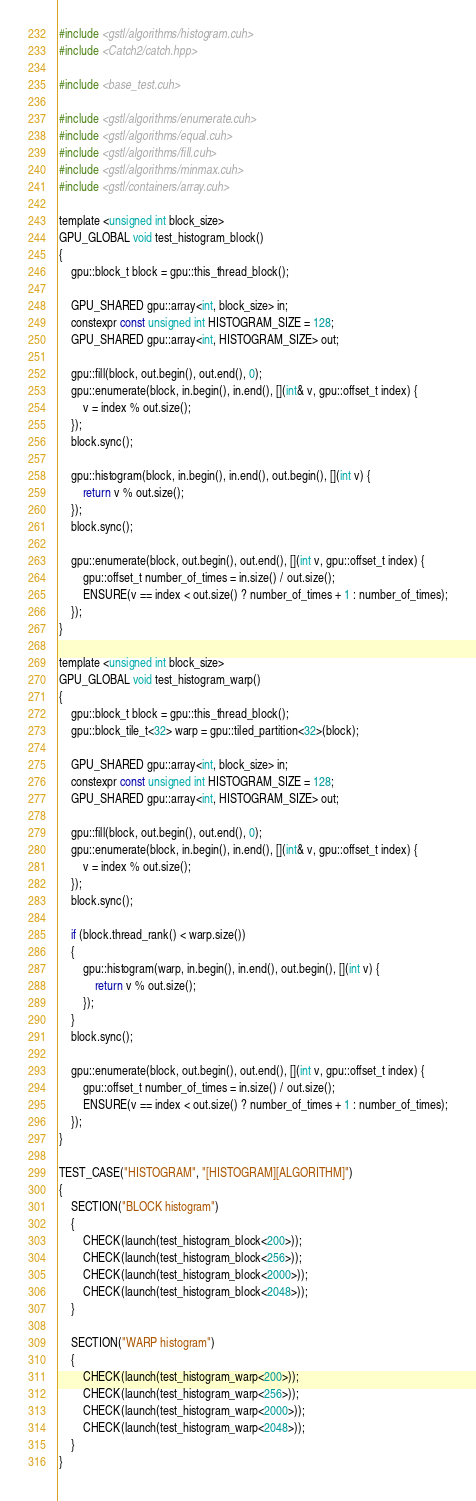Convert code to text. <code><loc_0><loc_0><loc_500><loc_500><_Cuda_>#include <gstl/algorithms/histogram.cuh>
#include <Catch2/catch.hpp>

#include <base_test.cuh>

#include <gstl/algorithms/enumerate.cuh>
#include <gstl/algorithms/equal.cuh>
#include <gstl/algorithms/fill.cuh>
#include <gstl/algorithms/minmax.cuh>
#include <gstl/containers/array.cuh>

template <unsigned int block_size>
GPU_GLOBAL void test_histogram_block()
{
	gpu::block_t block = gpu::this_thread_block();

	GPU_SHARED gpu::array<int, block_size> in;
	constexpr const unsigned int HISTOGRAM_SIZE = 128;
	GPU_SHARED gpu::array<int, HISTOGRAM_SIZE> out;

	gpu::fill(block, out.begin(), out.end(), 0);
	gpu::enumerate(block, in.begin(), in.end(), [](int& v, gpu::offset_t index) {
		v = index % out.size();
	});
	block.sync();

	gpu::histogram(block, in.begin(), in.end(), out.begin(), [](int v) {
		return v % out.size();
	});
	block.sync();

	gpu::enumerate(block, out.begin(), out.end(), [](int v, gpu::offset_t index) {
		gpu::offset_t number_of_times = in.size() / out.size();
		ENSURE(v == index < out.size() ? number_of_times + 1 : number_of_times);
	});
}

template <unsigned int block_size>
GPU_GLOBAL void test_histogram_warp()
{
	gpu::block_t block = gpu::this_thread_block();
	gpu::block_tile_t<32> warp = gpu::tiled_partition<32>(block);

	GPU_SHARED gpu::array<int, block_size> in;
	constexpr const unsigned int HISTOGRAM_SIZE = 128;
	GPU_SHARED gpu::array<int, HISTOGRAM_SIZE> out;

	gpu::fill(block, out.begin(), out.end(), 0);
	gpu::enumerate(block, in.begin(), in.end(), [](int& v, gpu::offset_t index) {
		v = index % out.size();
	});
	block.sync();

	if (block.thread_rank() < warp.size())
	{
		gpu::histogram(warp, in.begin(), in.end(), out.begin(), [](int v) {
			return v % out.size();
		});
	}
	block.sync();

	gpu::enumerate(block, out.begin(), out.end(), [](int v, gpu::offset_t index) {
		gpu::offset_t number_of_times = in.size() / out.size();
		ENSURE(v == index < out.size() ? number_of_times + 1 : number_of_times);
	});
}

TEST_CASE("HISTOGRAM", "[HISTOGRAM][ALGORITHM]")
{
	SECTION("BLOCK histogram")
	{
		CHECK(launch(test_histogram_block<200>));
		CHECK(launch(test_histogram_block<256>));
		CHECK(launch(test_histogram_block<2000>));
		CHECK(launch(test_histogram_block<2048>));
	}

	SECTION("WARP histogram")
	{
		CHECK(launch(test_histogram_warp<200>));
		CHECK(launch(test_histogram_warp<256>));
		CHECK(launch(test_histogram_warp<2000>));
		CHECK(launch(test_histogram_warp<2048>));
	}
}
</code> 